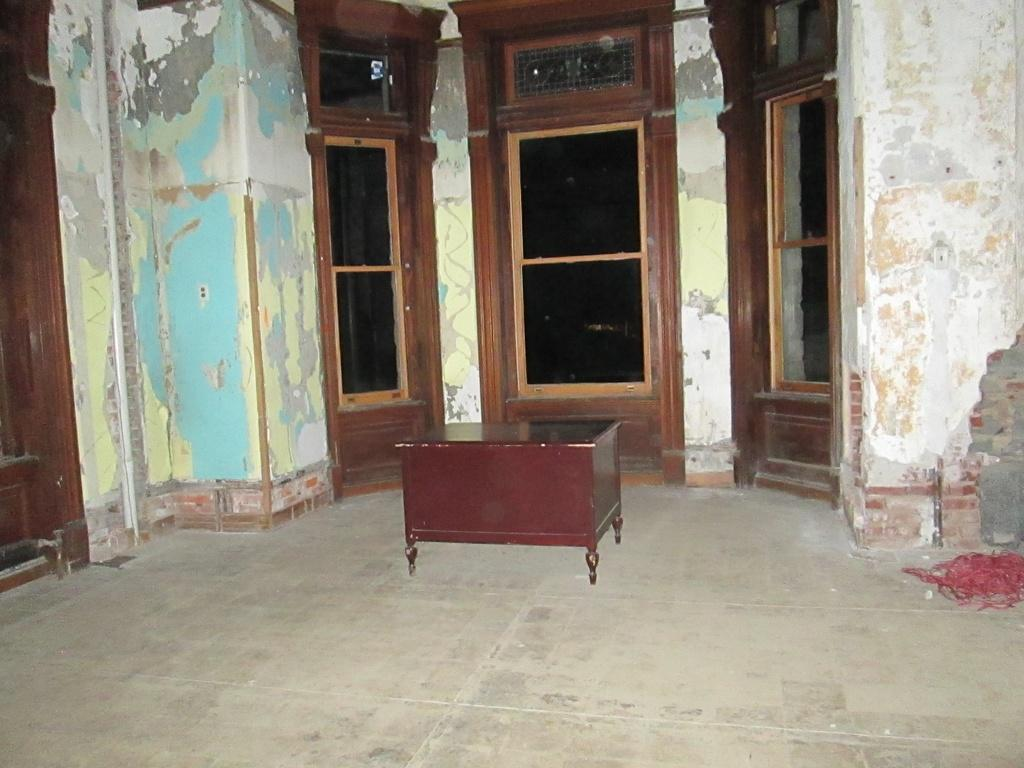What piece of furniture is present in the image? There is a table in the image. What is located on the floor in the image? There is an object on the floor in the image. What can be seen behind the table in the image? There are doors visible behind the table, and there is also a wall behind the table. What type of cloth is draped over the comb in the image? There is no cloth or comb present in the image. 